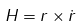Convert formula to latex. <formula><loc_0><loc_0><loc_500><loc_500>H = r \times \dot { r }</formula> 